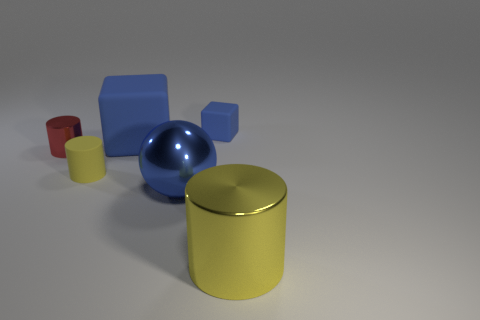What is the shape of the big blue shiny thing?
Give a very brief answer. Sphere. What number of tiny things have the same color as the large cylinder?
Make the answer very short. 1. What color is the large shiny object that is the same shape as the tiny yellow object?
Keep it short and to the point. Yellow. How many tiny red metallic objects are on the right side of the shiny cylinder to the right of the large blue ball?
Make the answer very short. 0. How many cubes are either big yellow things or small red shiny things?
Your answer should be compact. 0. Are any tiny blue matte cubes visible?
Give a very brief answer. Yes. What is the size of the other metal thing that is the same shape as the red metal object?
Provide a succinct answer. Large. The blue thing in front of the yellow object that is left of the yellow metallic object is what shape?
Make the answer very short. Sphere. What number of blue things are either large rubber objects or cylinders?
Your answer should be compact. 1. The large cylinder has what color?
Keep it short and to the point. Yellow. 